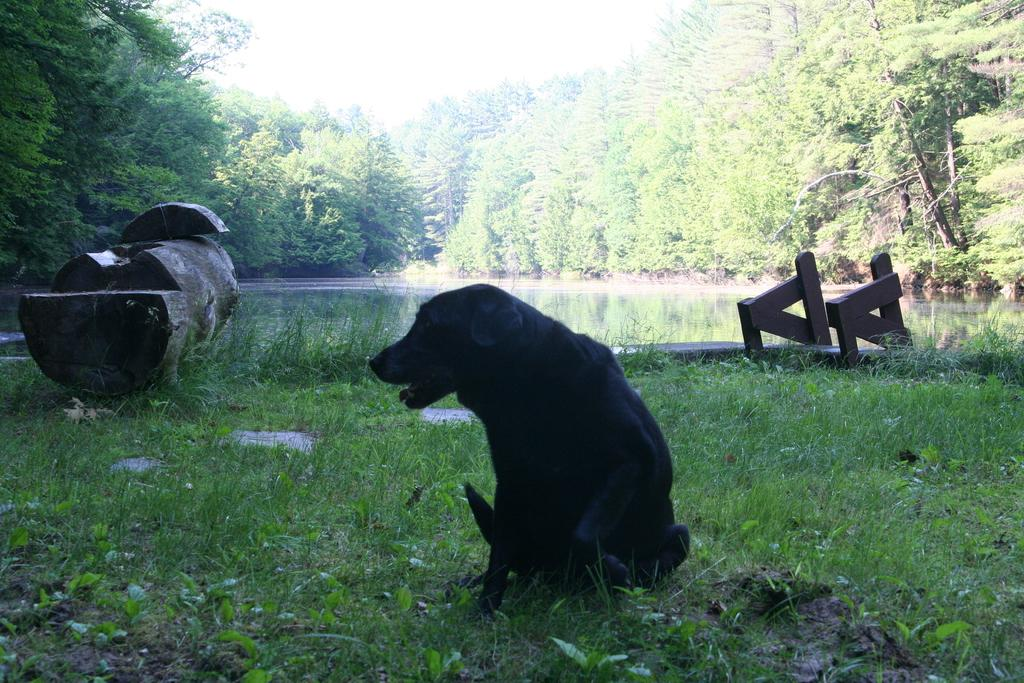What type of animal is in the image? There is a black dog in the image. Where is the dog located in the image? The dog is sitting on the grass. What can be seen in the background of the image? There are trees, plants, wooden logs, and other objects visible in the background. Is there any water visible in the image? Yes, there is water visible in the background of the image. How does the dog compare to the cat in the image? There is no cat present in the image, so it is not possible to make a comparison. 